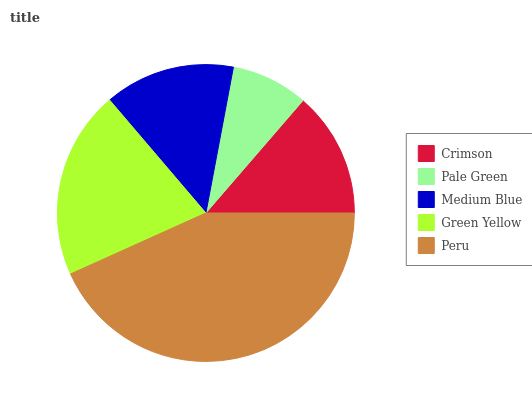Is Pale Green the minimum?
Answer yes or no. Yes. Is Peru the maximum?
Answer yes or no. Yes. Is Medium Blue the minimum?
Answer yes or no. No. Is Medium Blue the maximum?
Answer yes or no. No. Is Medium Blue greater than Pale Green?
Answer yes or no. Yes. Is Pale Green less than Medium Blue?
Answer yes or no. Yes. Is Pale Green greater than Medium Blue?
Answer yes or no. No. Is Medium Blue less than Pale Green?
Answer yes or no. No. Is Medium Blue the high median?
Answer yes or no. Yes. Is Medium Blue the low median?
Answer yes or no. Yes. Is Green Yellow the high median?
Answer yes or no. No. Is Peru the low median?
Answer yes or no. No. 